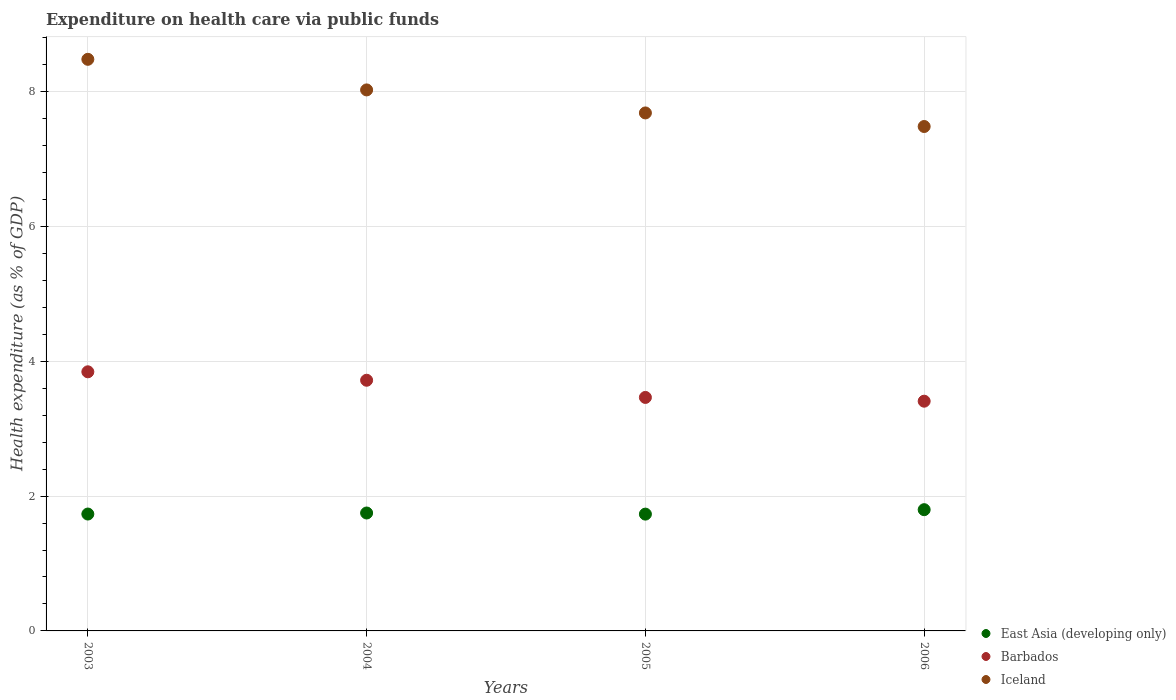What is the expenditure made on health care in Iceland in 2003?
Provide a short and direct response. 8.48. Across all years, what is the maximum expenditure made on health care in Barbados?
Your answer should be compact. 3.84. Across all years, what is the minimum expenditure made on health care in Iceland?
Ensure brevity in your answer.  7.48. In which year was the expenditure made on health care in East Asia (developing only) maximum?
Your response must be concise. 2006. What is the total expenditure made on health care in East Asia (developing only) in the graph?
Your answer should be very brief. 7.01. What is the difference between the expenditure made on health care in Iceland in 2004 and that in 2006?
Your answer should be very brief. 0.54. What is the difference between the expenditure made on health care in Iceland in 2004 and the expenditure made on health care in East Asia (developing only) in 2005?
Your response must be concise. 6.29. What is the average expenditure made on health care in Barbados per year?
Your answer should be very brief. 3.61. In the year 2005, what is the difference between the expenditure made on health care in East Asia (developing only) and expenditure made on health care in Iceland?
Ensure brevity in your answer.  -5.95. What is the ratio of the expenditure made on health care in East Asia (developing only) in 2004 to that in 2005?
Offer a terse response. 1.01. Is the difference between the expenditure made on health care in East Asia (developing only) in 2003 and 2006 greater than the difference between the expenditure made on health care in Iceland in 2003 and 2006?
Offer a very short reply. No. What is the difference between the highest and the second highest expenditure made on health care in East Asia (developing only)?
Keep it short and to the point. 0.05. What is the difference between the highest and the lowest expenditure made on health care in East Asia (developing only)?
Offer a very short reply. 0.07. Is the sum of the expenditure made on health care in Barbados in 2005 and 2006 greater than the maximum expenditure made on health care in East Asia (developing only) across all years?
Give a very brief answer. Yes. Is it the case that in every year, the sum of the expenditure made on health care in Iceland and expenditure made on health care in Barbados  is greater than the expenditure made on health care in East Asia (developing only)?
Provide a short and direct response. Yes. Is the expenditure made on health care in Iceland strictly greater than the expenditure made on health care in Barbados over the years?
Your answer should be very brief. Yes. How many years are there in the graph?
Provide a short and direct response. 4. Are the values on the major ticks of Y-axis written in scientific E-notation?
Make the answer very short. No. Does the graph contain any zero values?
Offer a very short reply. No. Where does the legend appear in the graph?
Your answer should be very brief. Bottom right. How many legend labels are there?
Provide a succinct answer. 3. How are the legend labels stacked?
Provide a short and direct response. Vertical. What is the title of the graph?
Ensure brevity in your answer.  Expenditure on health care via public funds. What is the label or title of the Y-axis?
Your answer should be compact. Health expenditure (as % of GDP). What is the Health expenditure (as % of GDP) in East Asia (developing only) in 2003?
Make the answer very short. 1.73. What is the Health expenditure (as % of GDP) of Barbados in 2003?
Your response must be concise. 3.84. What is the Health expenditure (as % of GDP) in Iceland in 2003?
Make the answer very short. 8.48. What is the Health expenditure (as % of GDP) of East Asia (developing only) in 2004?
Ensure brevity in your answer.  1.75. What is the Health expenditure (as % of GDP) in Barbados in 2004?
Your answer should be compact. 3.72. What is the Health expenditure (as % of GDP) of Iceland in 2004?
Your answer should be compact. 8.02. What is the Health expenditure (as % of GDP) of East Asia (developing only) in 2005?
Offer a very short reply. 1.73. What is the Health expenditure (as % of GDP) in Barbados in 2005?
Keep it short and to the point. 3.46. What is the Health expenditure (as % of GDP) of Iceland in 2005?
Your answer should be compact. 7.68. What is the Health expenditure (as % of GDP) of East Asia (developing only) in 2006?
Make the answer very short. 1.8. What is the Health expenditure (as % of GDP) in Barbados in 2006?
Your response must be concise. 3.41. What is the Health expenditure (as % of GDP) in Iceland in 2006?
Your answer should be compact. 7.48. Across all years, what is the maximum Health expenditure (as % of GDP) of East Asia (developing only)?
Provide a short and direct response. 1.8. Across all years, what is the maximum Health expenditure (as % of GDP) of Barbados?
Your response must be concise. 3.84. Across all years, what is the maximum Health expenditure (as % of GDP) in Iceland?
Offer a terse response. 8.48. Across all years, what is the minimum Health expenditure (as % of GDP) of East Asia (developing only)?
Make the answer very short. 1.73. Across all years, what is the minimum Health expenditure (as % of GDP) of Barbados?
Give a very brief answer. 3.41. Across all years, what is the minimum Health expenditure (as % of GDP) of Iceland?
Provide a succinct answer. 7.48. What is the total Health expenditure (as % of GDP) of East Asia (developing only) in the graph?
Keep it short and to the point. 7.01. What is the total Health expenditure (as % of GDP) of Barbados in the graph?
Your answer should be compact. 14.43. What is the total Health expenditure (as % of GDP) of Iceland in the graph?
Offer a terse response. 31.67. What is the difference between the Health expenditure (as % of GDP) of East Asia (developing only) in 2003 and that in 2004?
Offer a very short reply. -0.02. What is the difference between the Health expenditure (as % of GDP) in Barbados in 2003 and that in 2004?
Give a very brief answer. 0.13. What is the difference between the Health expenditure (as % of GDP) in Iceland in 2003 and that in 2004?
Your answer should be very brief. 0.45. What is the difference between the Health expenditure (as % of GDP) of East Asia (developing only) in 2003 and that in 2005?
Provide a succinct answer. 0. What is the difference between the Health expenditure (as % of GDP) in Barbados in 2003 and that in 2005?
Ensure brevity in your answer.  0.38. What is the difference between the Health expenditure (as % of GDP) in Iceland in 2003 and that in 2005?
Give a very brief answer. 0.8. What is the difference between the Health expenditure (as % of GDP) in East Asia (developing only) in 2003 and that in 2006?
Make the answer very short. -0.06. What is the difference between the Health expenditure (as % of GDP) in Barbados in 2003 and that in 2006?
Keep it short and to the point. 0.44. What is the difference between the Health expenditure (as % of GDP) in East Asia (developing only) in 2004 and that in 2005?
Provide a short and direct response. 0.02. What is the difference between the Health expenditure (as % of GDP) in Barbados in 2004 and that in 2005?
Offer a very short reply. 0.25. What is the difference between the Health expenditure (as % of GDP) in Iceland in 2004 and that in 2005?
Ensure brevity in your answer.  0.34. What is the difference between the Health expenditure (as % of GDP) in East Asia (developing only) in 2004 and that in 2006?
Your answer should be compact. -0.05. What is the difference between the Health expenditure (as % of GDP) of Barbados in 2004 and that in 2006?
Your response must be concise. 0.31. What is the difference between the Health expenditure (as % of GDP) of Iceland in 2004 and that in 2006?
Ensure brevity in your answer.  0.54. What is the difference between the Health expenditure (as % of GDP) in East Asia (developing only) in 2005 and that in 2006?
Provide a short and direct response. -0.07. What is the difference between the Health expenditure (as % of GDP) of Barbados in 2005 and that in 2006?
Provide a succinct answer. 0.06. What is the difference between the Health expenditure (as % of GDP) of Iceland in 2005 and that in 2006?
Give a very brief answer. 0.2. What is the difference between the Health expenditure (as % of GDP) in East Asia (developing only) in 2003 and the Health expenditure (as % of GDP) in Barbados in 2004?
Your response must be concise. -1.98. What is the difference between the Health expenditure (as % of GDP) of East Asia (developing only) in 2003 and the Health expenditure (as % of GDP) of Iceland in 2004?
Keep it short and to the point. -6.29. What is the difference between the Health expenditure (as % of GDP) of Barbados in 2003 and the Health expenditure (as % of GDP) of Iceland in 2004?
Make the answer very short. -4.18. What is the difference between the Health expenditure (as % of GDP) in East Asia (developing only) in 2003 and the Health expenditure (as % of GDP) in Barbados in 2005?
Provide a succinct answer. -1.73. What is the difference between the Health expenditure (as % of GDP) in East Asia (developing only) in 2003 and the Health expenditure (as % of GDP) in Iceland in 2005?
Offer a very short reply. -5.95. What is the difference between the Health expenditure (as % of GDP) in Barbados in 2003 and the Health expenditure (as % of GDP) in Iceland in 2005?
Your answer should be compact. -3.84. What is the difference between the Health expenditure (as % of GDP) in East Asia (developing only) in 2003 and the Health expenditure (as % of GDP) in Barbados in 2006?
Ensure brevity in your answer.  -1.67. What is the difference between the Health expenditure (as % of GDP) in East Asia (developing only) in 2003 and the Health expenditure (as % of GDP) in Iceland in 2006?
Keep it short and to the point. -5.75. What is the difference between the Health expenditure (as % of GDP) in Barbados in 2003 and the Health expenditure (as % of GDP) in Iceland in 2006?
Offer a very short reply. -3.64. What is the difference between the Health expenditure (as % of GDP) of East Asia (developing only) in 2004 and the Health expenditure (as % of GDP) of Barbados in 2005?
Provide a succinct answer. -1.71. What is the difference between the Health expenditure (as % of GDP) of East Asia (developing only) in 2004 and the Health expenditure (as % of GDP) of Iceland in 2005?
Your response must be concise. -5.93. What is the difference between the Health expenditure (as % of GDP) in Barbados in 2004 and the Health expenditure (as % of GDP) in Iceland in 2005?
Provide a short and direct response. -3.96. What is the difference between the Health expenditure (as % of GDP) of East Asia (developing only) in 2004 and the Health expenditure (as % of GDP) of Barbados in 2006?
Keep it short and to the point. -1.66. What is the difference between the Health expenditure (as % of GDP) of East Asia (developing only) in 2004 and the Health expenditure (as % of GDP) of Iceland in 2006?
Offer a terse response. -5.73. What is the difference between the Health expenditure (as % of GDP) of Barbados in 2004 and the Health expenditure (as % of GDP) of Iceland in 2006?
Your answer should be compact. -3.76. What is the difference between the Health expenditure (as % of GDP) of East Asia (developing only) in 2005 and the Health expenditure (as % of GDP) of Barbados in 2006?
Give a very brief answer. -1.68. What is the difference between the Health expenditure (as % of GDP) in East Asia (developing only) in 2005 and the Health expenditure (as % of GDP) in Iceland in 2006?
Ensure brevity in your answer.  -5.75. What is the difference between the Health expenditure (as % of GDP) in Barbados in 2005 and the Health expenditure (as % of GDP) in Iceland in 2006?
Offer a very short reply. -4.02. What is the average Health expenditure (as % of GDP) in East Asia (developing only) per year?
Make the answer very short. 1.75. What is the average Health expenditure (as % of GDP) of Barbados per year?
Provide a short and direct response. 3.61. What is the average Health expenditure (as % of GDP) of Iceland per year?
Provide a succinct answer. 7.92. In the year 2003, what is the difference between the Health expenditure (as % of GDP) in East Asia (developing only) and Health expenditure (as % of GDP) in Barbados?
Offer a very short reply. -2.11. In the year 2003, what is the difference between the Health expenditure (as % of GDP) of East Asia (developing only) and Health expenditure (as % of GDP) of Iceland?
Give a very brief answer. -6.74. In the year 2003, what is the difference between the Health expenditure (as % of GDP) in Barbados and Health expenditure (as % of GDP) in Iceland?
Provide a short and direct response. -4.63. In the year 2004, what is the difference between the Health expenditure (as % of GDP) in East Asia (developing only) and Health expenditure (as % of GDP) in Barbados?
Provide a succinct answer. -1.97. In the year 2004, what is the difference between the Health expenditure (as % of GDP) in East Asia (developing only) and Health expenditure (as % of GDP) in Iceland?
Your answer should be compact. -6.28. In the year 2004, what is the difference between the Health expenditure (as % of GDP) of Barbados and Health expenditure (as % of GDP) of Iceland?
Make the answer very short. -4.31. In the year 2005, what is the difference between the Health expenditure (as % of GDP) in East Asia (developing only) and Health expenditure (as % of GDP) in Barbados?
Your answer should be very brief. -1.73. In the year 2005, what is the difference between the Health expenditure (as % of GDP) in East Asia (developing only) and Health expenditure (as % of GDP) in Iceland?
Keep it short and to the point. -5.95. In the year 2005, what is the difference between the Health expenditure (as % of GDP) of Barbados and Health expenditure (as % of GDP) of Iceland?
Your answer should be very brief. -4.22. In the year 2006, what is the difference between the Health expenditure (as % of GDP) in East Asia (developing only) and Health expenditure (as % of GDP) in Barbados?
Your answer should be compact. -1.61. In the year 2006, what is the difference between the Health expenditure (as % of GDP) of East Asia (developing only) and Health expenditure (as % of GDP) of Iceland?
Your answer should be very brief. -5.68. In the year 2006, what is the difference between the Health expenditure (as % of GDP) of Barbados and Health expenditure (as % of GDP) of Iceland?
Your answer should be very brief. -4.07. What is the ratio of the Health expenditure (as % of GDP) in East Asia (developing only) in 2003 to that in 2004?
Your answer should be very brief. 0.99. What is the ratio of the Health expenditure (as % of GDP) of Barbados in 2003 to that in 2004?
Offer a very short reply. 1.03. What is the ratio of the Health expenditure (as % of GDP) in Iceland in 2003 to that in 2004?
Offer a terse response. 1.06. What is the ratio of the Health expenditure (as % of GDP) in Barbados in 2003 to that in 2005?
Provide a succinct answer. 1.11. What is the ratio of the Health expenditure (as % of GDP) of Iceland in 2003 to that in 2005?
Your answer should be compact. 1.1. What is the ratio of the Health expenditure (as % of GDP) of Barbados in 2003 to that in 2006?
Make the answer very short. 1.13. What is the ratio of the Health expenditure (as % of GDP) in Iceland in 2003 to that in 2006?
Offer a terse response. 1.13. What is the ratio of the Health expenditure (as % of GDP) in East Asia (developing only) in 2004 to that in 2005?
Offer a very short reply. 1.01. What is the ratio of the Health expenditure (as % of GDP) in Barbados in 2004 to that in 2005?
Your answer should be compact. 1.07. What is the ratio of the Health expenditure (as % of GDP) of Iceland in 2004 to that in 2005?
Your answer should be very brief. 1.04. What is the ratio of the Health expenditure (as % of GDP) in East Asia (developing only) in 2004 to that in 2006?
Your answer should be compact. 0.97. What is the ratio of the Health expenditure (as % of GDP) in Barbados in 2004 to that in 2006?
Offer a very short reply. 1.09. What is the ratio of the Health expenditure (as % of GDP) of Iceland in 2004 to that in 2006?
Offer a very short reply. 1.07. What is the ratio of the Health expenditure (as % of GDP) of East Asia (developing only) in 2005 to that in 2006?
Make the answer very short. 0.96. What is the ratio of the Health expenditure (as % of GDP) in Barbados in 2005 to that in 2006?
Offer a very short reply. 1.02. What is the ratio of the Health expenditure (as % of GDP) of Iceland in 2005 to that in 2006?
Provide a succinct answer. 1.03. What is the difference between the highest and the second highest Health expenditure (as % of GDP) of East Asia (developing only)?
Give a very brief answer. 0.05. What is the difference between the highest and the second highest Health expenditure (as % of GDP) of Barbados?
Provide a succinct answer. 0.13. What is the difference between the highest and the second highest Health expenditure (as % of GDP) in Iceland?
Make the answer very short. 0.45. What is the difference between the highest and the lowest Health expenditure (as % of GDP) of East Asia (developing only)?
Offer a terse response. 0.07. What is the difference between the highest and the lowest Health expenditure (as % of GDP) in Barbados?
Provide a succinct answer. 0.44. What is the difference between the highest and the lowest Health expenditure (as % of GDP) in Iceland?
Make the answer very short. 1. 